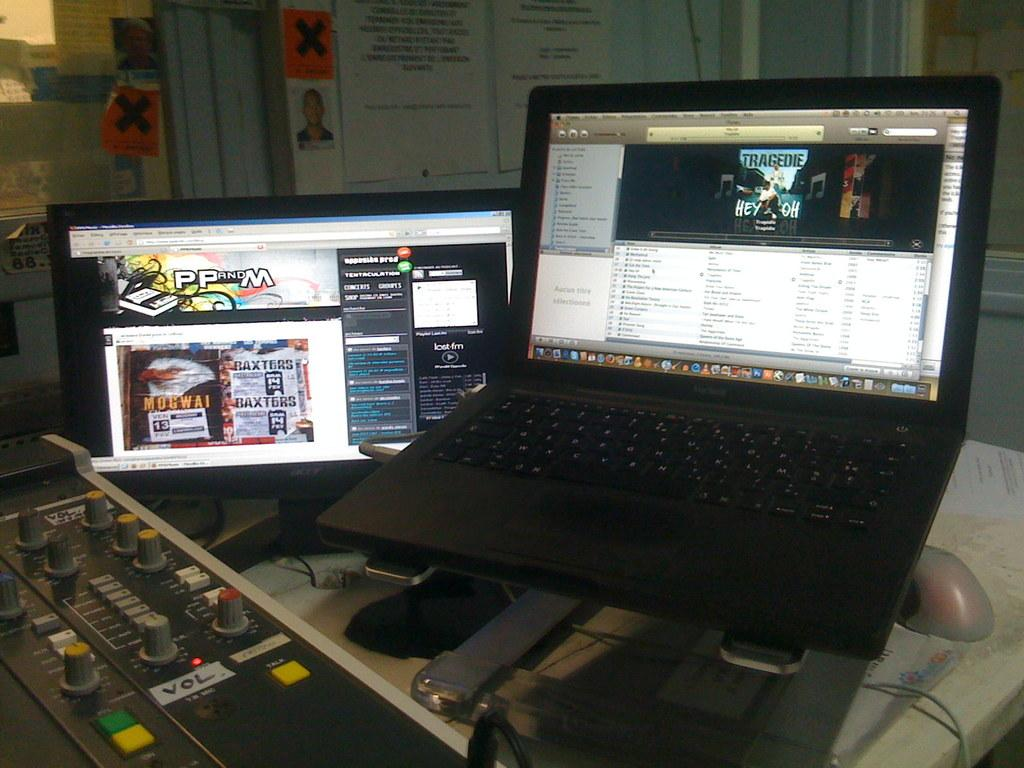<image>
Describe the image concisely. a mixing desk beside a laptop and computer monitor which is displaying a website titled PPandM 